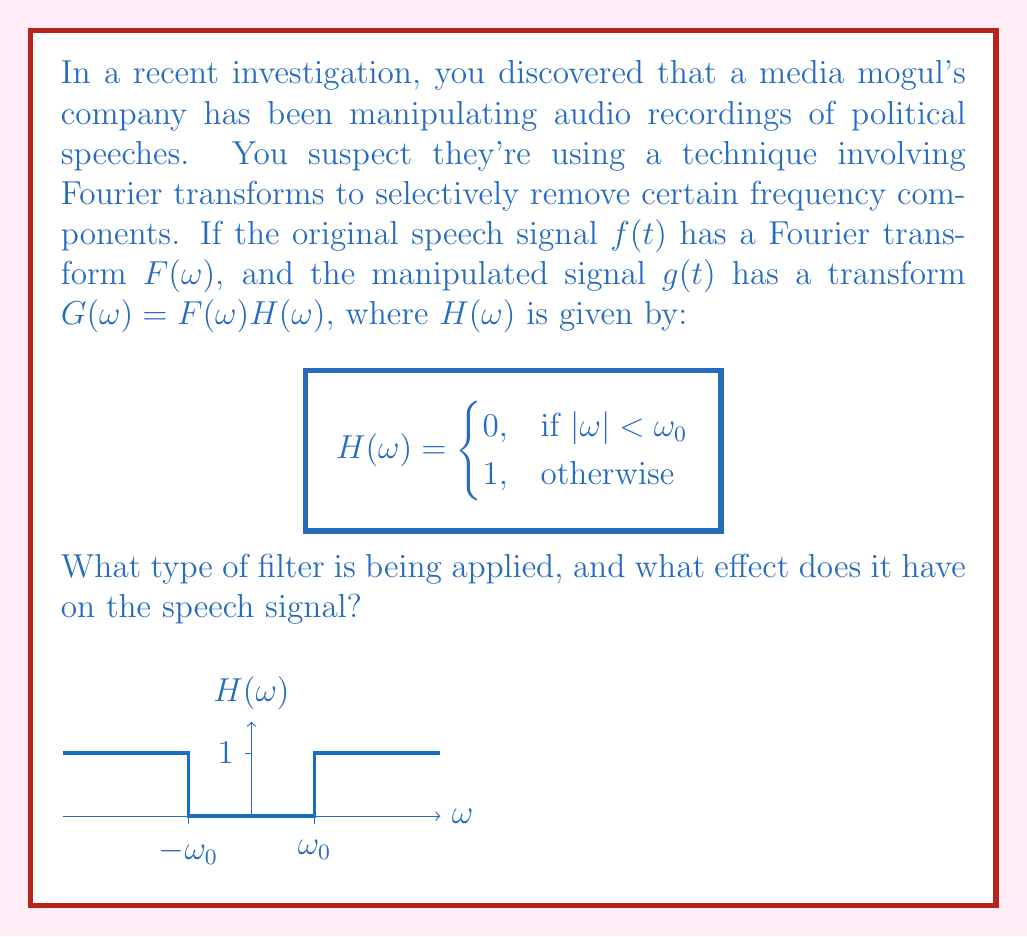Teach me how to tackle this problem. To understand the effect of this filter, let's analyze it step by step:

1) The function $H(\omega)$ is defined as:
   $$H(\omega) = \begin{cases}
   0, & \text{if } |\omega| < \omega_0 \\
   1, & \text{otherwise}
   \end{cases}$$

2) This function essentially removes all frequency components below $\omega_0$ and above $-\omega_0$, while keeping all other frequencies unchanged.

3) In signal processing terms, this is known as a high-pass filter. It "passes" high frequencies and attenuates (in this case, completely removes) low frequencies.

4) The effect on the speech signal can be understood by considering the frequency content of human speech:

   a) Most of the energy in human speech is concentrated in lower frequencies (typically below 4000 Hz).
   b) Lower frequencies carry information about the fundamental frequency (pitch) and lower formants, which are crucial for speech intelligibility and speaker identification.

5) By applying this high-pass filter:

   a) The lower frequency components of the speech are removed.
   b) This results in the loss of the speaker's fundamental frequency and lower formants.

6) The consequences of this manipulation include:

   a) The speech may sound thin or tinny.
   b) The speaker's voice may become less recognizable.
   c) Some consonant sounds may be emphasized while vowel sounds are de-emphasized.
   d) The overall intelligibility of the speech may be reduced, especially for certain phonemes.

In the context of media manipulation, this technique could be used to subtly alter the perceived characteristics of a speaker's voice, potentially making it sound less authoritative or changing its emotional tone.
Answer: High-pass filter; removes low frequencies, altering voice characteristics and potentially reducing intelligibility. 